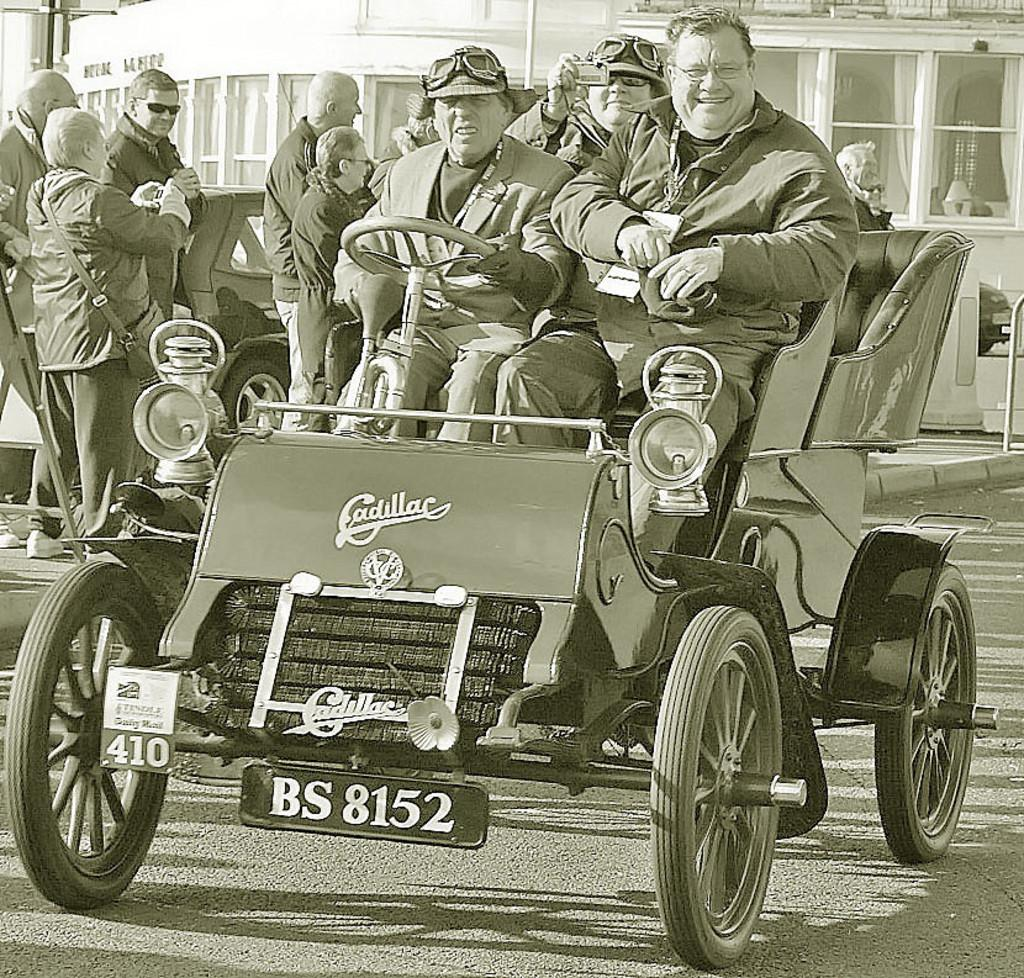What type of structure is present in the image? There is a building in the image. What mode of transportation can be seen in the image? There is a car and a truck in the image. Are there any individuals visible in the image? Yes, there are people visible in the image. Can you describe the ocean visible in the image? There is no ocean present in the image; it features a building, a car, a truck, and people. How many feet are visible in the image? There is no specific mention of feet in the image, as it focuses on a building, a car, a truck, and people. 